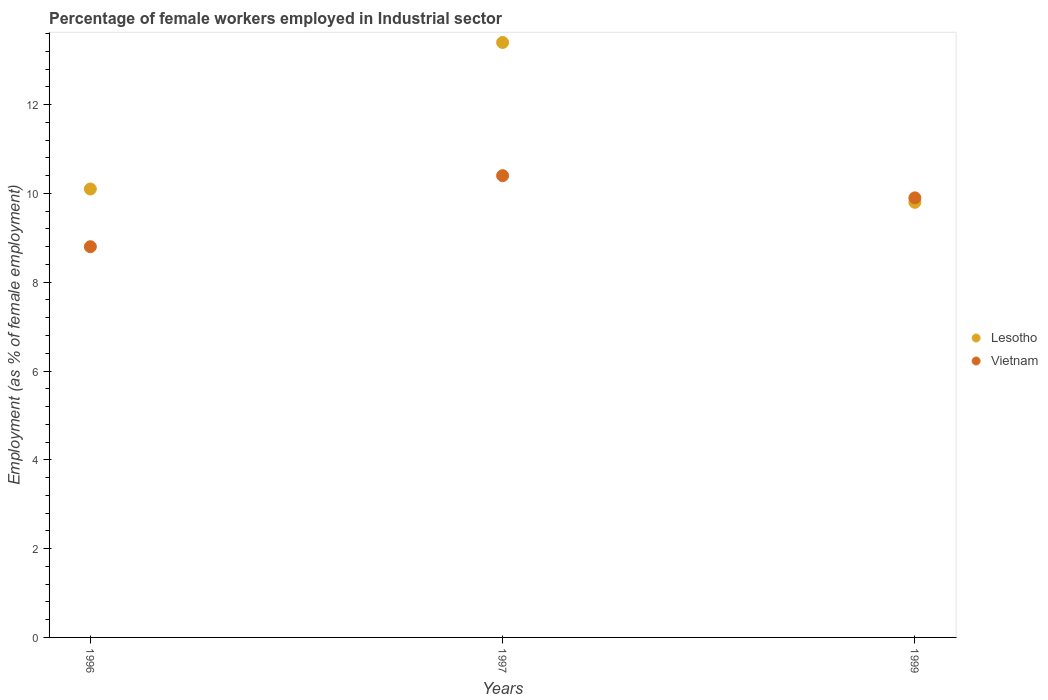Is the number of dotlines equal to the number of legend labels?
Provide a succinct answer. Yes. What is the percentage of females employed in Industrial sector in Lesotho in 1997?
Provide a short and direct response. 13.4. Across all years, what is the maximum percentage of females employed in Industrial sector in Vietnam?
Provide a short and direct response. 10.4. Across all years, what is the minimum percentage of females employed in Industrial sector in Lesotho?
Provide a succinct answer. 9.8. In which year was the percentage of females employed in Industrial sector in Vietnam minimum?
Keep it short and to the point. 1996. What is the total percentage of females employed in Industrial sector in Lesotho in the graph?
Your response must be concise. 33.3. What is the difference between the percentage of females employed in Industrial sector in Vietnam in 1996 and that in 1999?
Give a very brief answer. -1.1. What is the average percentage of females employed in Industrial sector in Vietnam per year?
Make the answer very short. 9.7. In the year 1999, what is the difference between the percentage of females employed in Industrial sector in Lesotho and percentage of females employed in Industrial sector in Vietnam?
Provide a short and direct response. -0.1. In how many years, is the percentage of females employed in Industrial sector in Vietnam greater than 3.2 %?
Ensure brevity in your answer.  3. What is the ratio of the percentage of females employed in Industrial sector in Vietnam in 1997 to that in 1999?
Your answer should be very brief. 1.05. What is the difference between the highest and the second highest percentage of females employed in Industrial sector in Lesotho?
Make the answer very short. 3.3. What is the difference between the highest and the lowest percentage of females employed in Industrial sector in Lesotho?
Make the answer very short. 3.6. In how many years, is the percentage of females employed in Industrial sector in Vietnam greater than the average percentage of females employed in Industrial sector in Vietnam taken over all years?
Your answer should be very brief. 2. Does the percentage of females employed in Industrial sector in Lesotho monotonically increase over the years?
Your answer should be compact. No. Is the percentage of females employed in Industrial sector in Vietnam strictly less than the percentage of females employed in Industrial sector in Lesotho over the years?
Ensure brevity in your answer.  No. How many years are there in the graph?
Offer a terse response. 3. What is the difference between two consecutive major ticks on the Y-axis?
Offer a very short reply. 2. Are the values on the major ticks of Y-axis written in scientific E-notation?
Provide a succinct answer. No. Does the graph contain any zero values?
Provide a succinct answer. No. Does the graph contain grids?
Your response must be concise. No. Where does the legend appear in the graph?
Make the answer very short. Center right. How are the legend labels stacked?
Offer a very short reply. Vertical. What is the title of the graph?
Ensure brevity in your answer.  Percentage of female workers employed in Industrial sector. What is the label or title of the X-axis?
Provide a succinct answer. Years. What is the label or title of the Y-axis?
Your response must be concise. Employment (as % of female employment). What is the Employment (as % of female employment) of Lesotho in 1996?
Your response must be concise. 10.1. What is the Employment (as % of female employment) in Vietnam in 1996?
Give a very brief answer. 8.8. What is the Employment (as % of female employment) of Lesotho in 1997?
Your response must be concise. 13.4. What is the Employment (as % of female employment) of Vietnam in 1997?
Provide a short and direct response. 10.4. What is the Employment (as % of female employment) of Lesotho in 1999?
Offer a terse response. 9.8. What is the Employment (as % of female employment) in Vietnam in 1999?
Your answer should be very brief. 9.9. Across all years, what is the maximum Employment (as % of female employment) in Lesotho?
Provide a short and direct response. 13.4. Across all years, what is the maximum Employment (as % of female employment) of Vietnam?
Your answer should be very brief. 10.4. Across all years, what is the minimum Employment (as % of female employment) in Lesotho?
Offer a very short reply. 9.8. Across all years, what is the minimum Employment (as % of female employment) of Vietnam?
Your response must be concise. 8.8. What is the total Employment (as % of female employment) of Lesotho in the graph?
Provide a succinct answer. 33.3. What is the total Employment (as % of female employment) of Vietnam in the graph?
Give a very brief answer. 29.1. What is the difference between the Employment (as % of female employment) of Lesotho in 1996 and the Employment (as % of female employment) of Vietnam in 1997?
Your answer should be very brief. -0.3. What is the difference between the Employment (as % of female employment) of Lesotho in 1997 and the Employment (as % of female employment) of Vietnam in 1999?
Provide a short and direct response. 3.5. What is the average Employment (as % of female employment) of Lesotho per year?
Provide a succinct answer. 11.1. In the year 1996, what is the difference between the Employment (as % of female employment) in Lesotho and Employment (as % of female employment) in Vietnam?
Provide a short and direct response. 1.3. In the year 1997, what is the difference between the Employment (as % of female employment) of Lesotho and Employment (as % of female employment) of Vietnam?
Your answer should be compact. 3. What is the ratio of the Employment (as % of female employment) of Lesotho in 1996 to that in 1997?
Provide a succinct answer. 0.75. What is the ratio of the Employment (as % of female employment) of Vietnam in 1996 to that in 1997?
Make the answer very short. 0.85. What is the ratio of the Employment (as % of female employment) of Lesotho in 1996 to that in 1999?
Your answer should be very brief. 1.03. What is the ratio of the Employment (as % of female employment) in Lesotho in 1997 to that in 1999?
Your answer should be compact. 1.37. What is the ratio of the Employment (as % of female employment) of Vietnam in 1997 to that in 1999?
Offer a very short reply. 1.05. What is the difference between the highest and the second highest Employment (as % of female employment) of Vietnam?
Keep it short and to the point. 0.5. What is the difference between the highest and the lowest Employment (as % of female employment) of Lesotho?
Give a very brief answer. 3.6. What is the difference between the highest and the lowest Employment (as % of female employment) in Vietnam?
Provide a succinct answer. 1.6. 